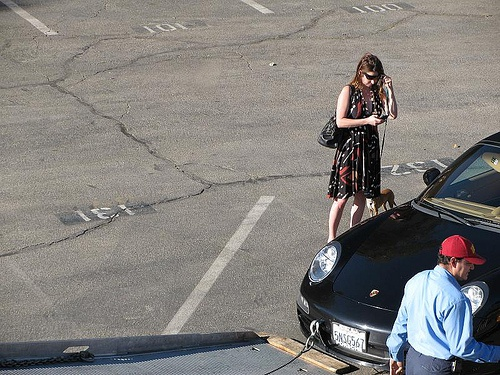Describe the objects in this image and their specific colors. I can see car in gray, black, white, and darkgray tones, truck in gray, darkgray, black, and navy tones, people in gray, lightblue, black, and navy tones, people in gray, black, maroon, and white tones, and handbag in gray, black, darkgray, and lightgray tones in this image. 